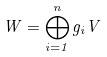Convert formula to latex. <formula><loc_0><loc_0><loc_500><loc_500>W = \bigoplus _ { i = 1 } ^ { n } g _ { i } V</formula> 